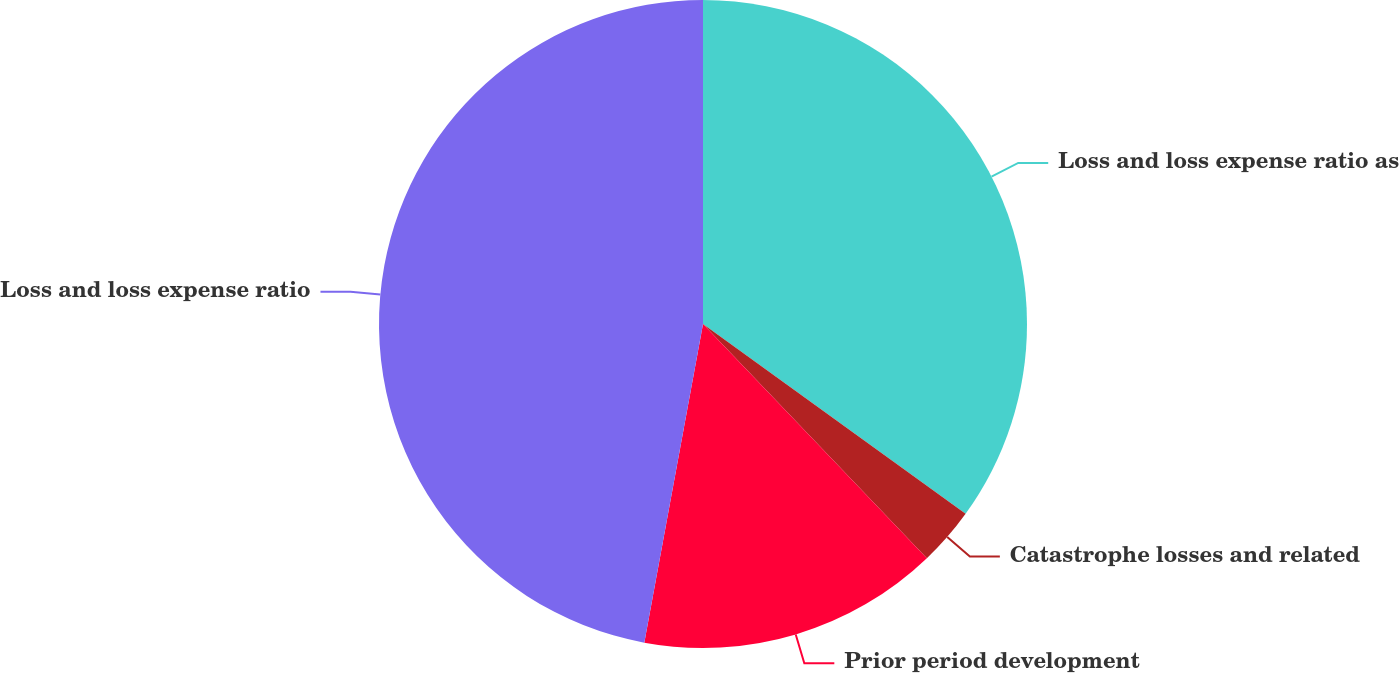Convert chart. <chart><loc_0><loc_0><loc_500><loc_500><pie_chart><fcel>Loss and loss expense ratio as<fcel>Catastrophe losses and related<fcel>Prior period development<fcel>Loss and loss expense ratio<nl><fcel>34.96%<fcel>2.9%<fcel>15.04%<fcel>47.1%<nl></chart> 